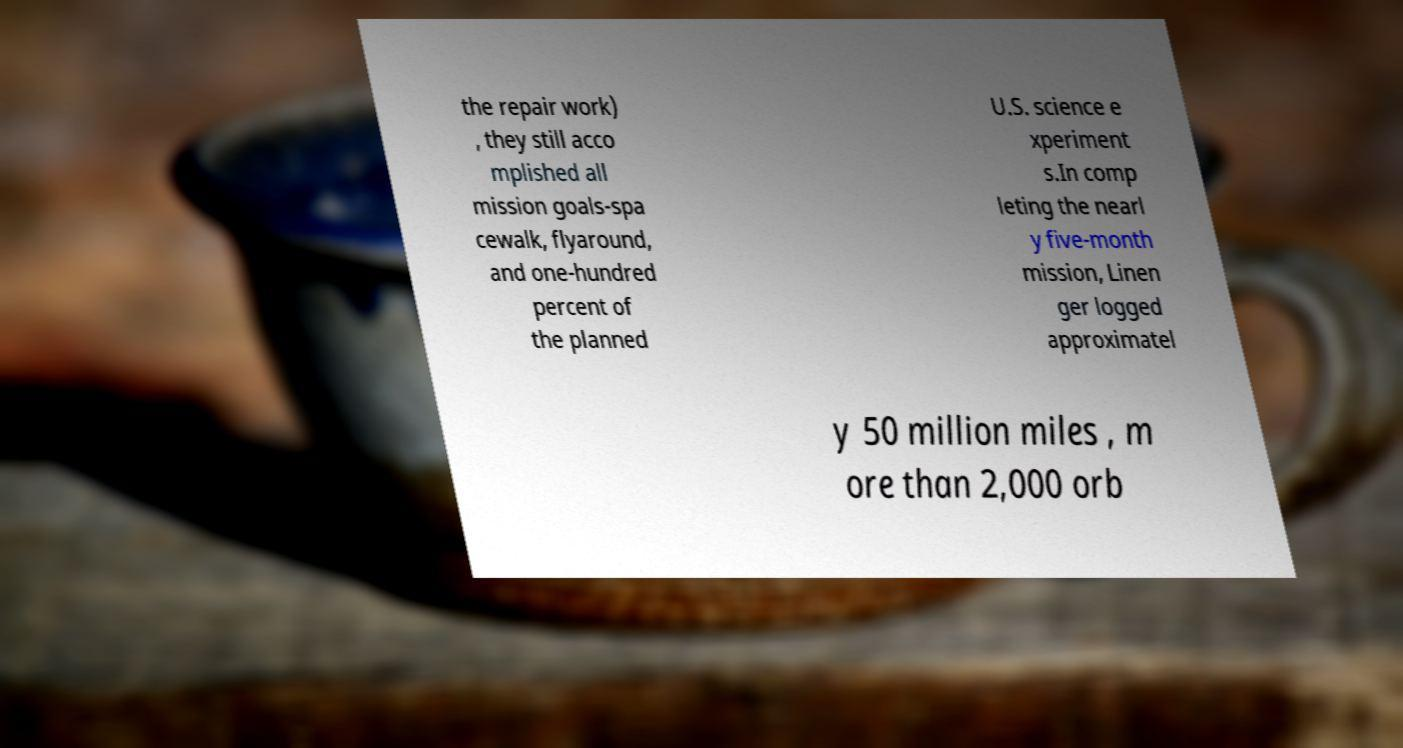Please identify and transcribe the text found in this image. the repair work) , they still acco mplished all mission goals-spa cewalk, flyaround, and one-hundred percent of the planned U.S. science e xperiment s.In comp leting the nearl y five-month mission, Linen ger logged approximatel y 50 million miles , m ore than 2,000 orb 